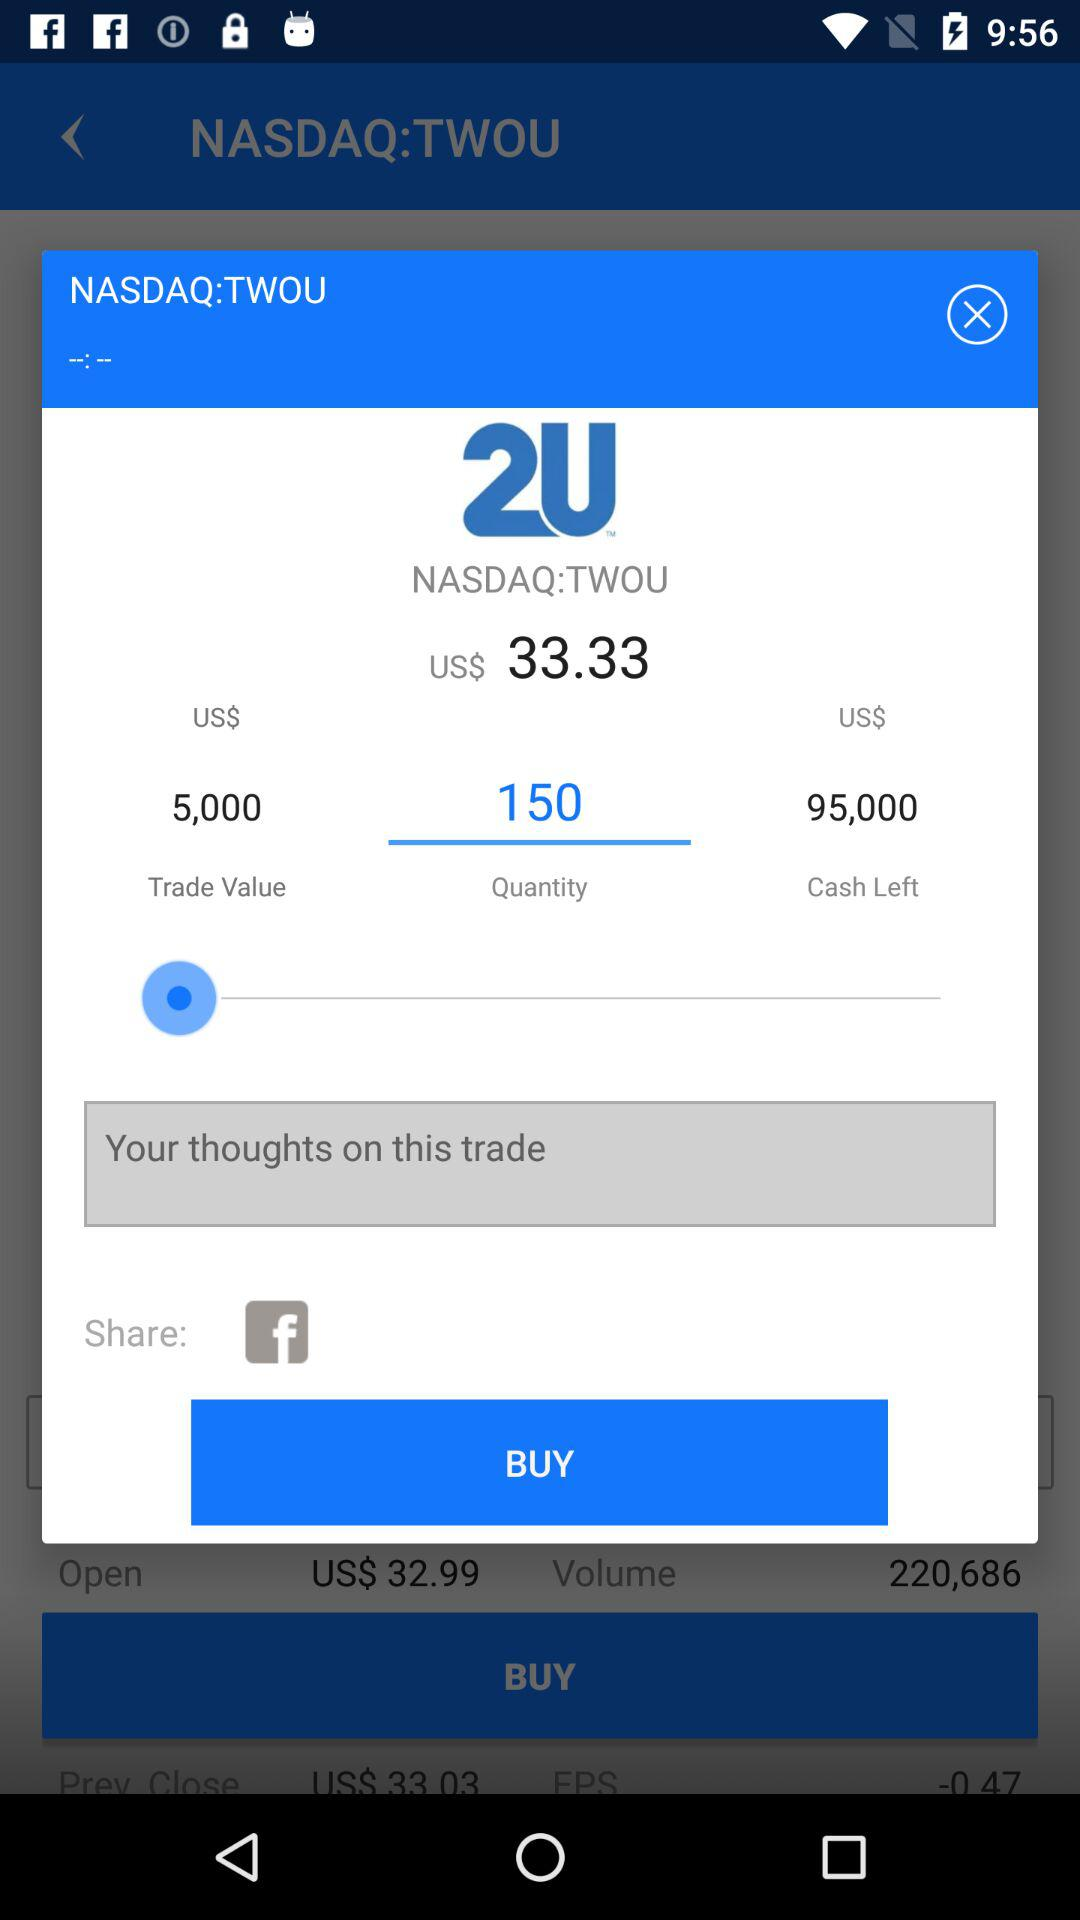What's the value of trade? The value is $5000. 